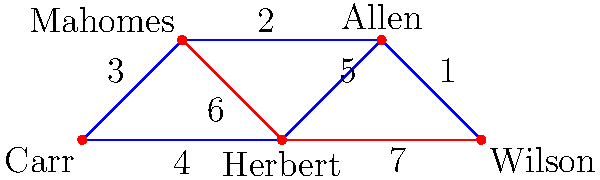In a graph representing NFL quarterbacks, where edges represent statistical similarities (lower weight means more similar), what is the total weight of the minimum spanning tree that includes Derek Carr? Which quarterback is most statistically similar to Carr in this minimum spanning tree? To solve this problem, we'll use Kruskal's algorithm to find the minimum spanning tree (MST):

1. Sort edges by weight:
   (Allen-Wilson): 1
   (Mahomes-Allen): 2
   (Carr-Mahomes): 3
   (Carr-Herbert): 4
   (Herbert-Allen): 5
   (Mahomes-Herbert): 6
   (Herbert-Wilson): 7

2. Add edges to the MST, avoiding cycles:
   - Add (Allen-Wilson): 1
   - Add (Mahomes-Allen): 2
   - Add (Carr-Mahomes): 3
   - Add (Carr-Herbert): 4

3. The MST is complete with 4 edges connecting 5 vertices.

4. Calculate total weight: 1 + 2 + 3 + 4 = 10

5. In the MST, Carr is directly connected to Mahomes with weight 3, which is the lowest weight edge connected to Carr.

Therefore, the total weight of the MST is 10, and Mahomes is most statistically similar to Carr in this MST.
Answer: Total weight: 10; Most similar: Mahomes 